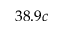<formula> <loc_0><loc_0><loc_500><loc_500>3 8 . 9 c</formula> 